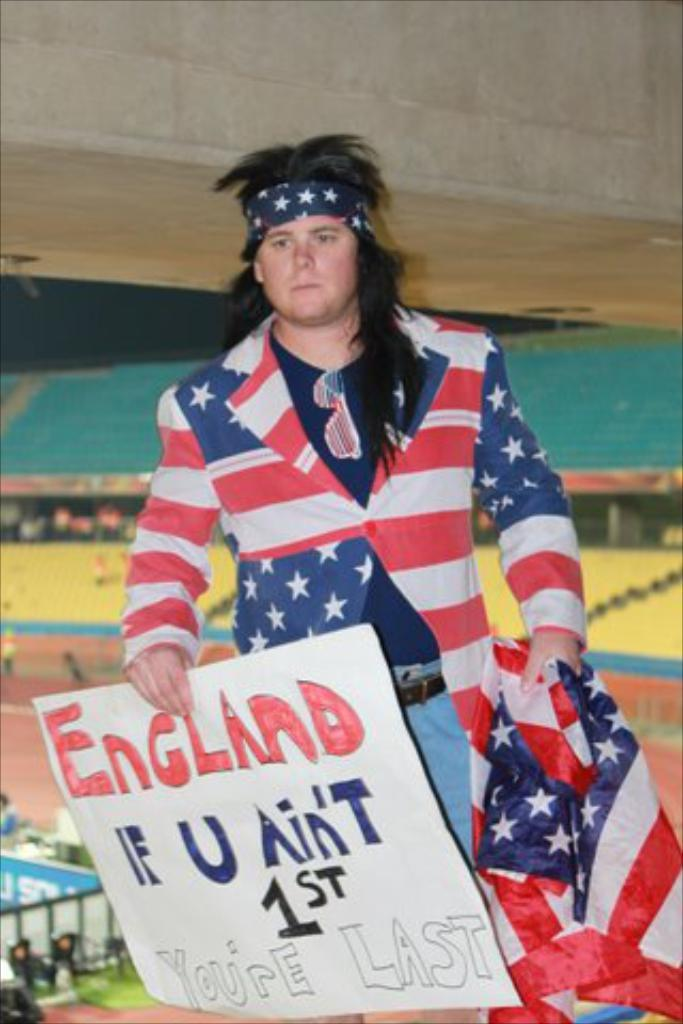<image>
Offer a succinct explanation of the picture presented. a man in a long black wig and american flag suit holds up a sign saying "england if u ain't 1st you're last" 